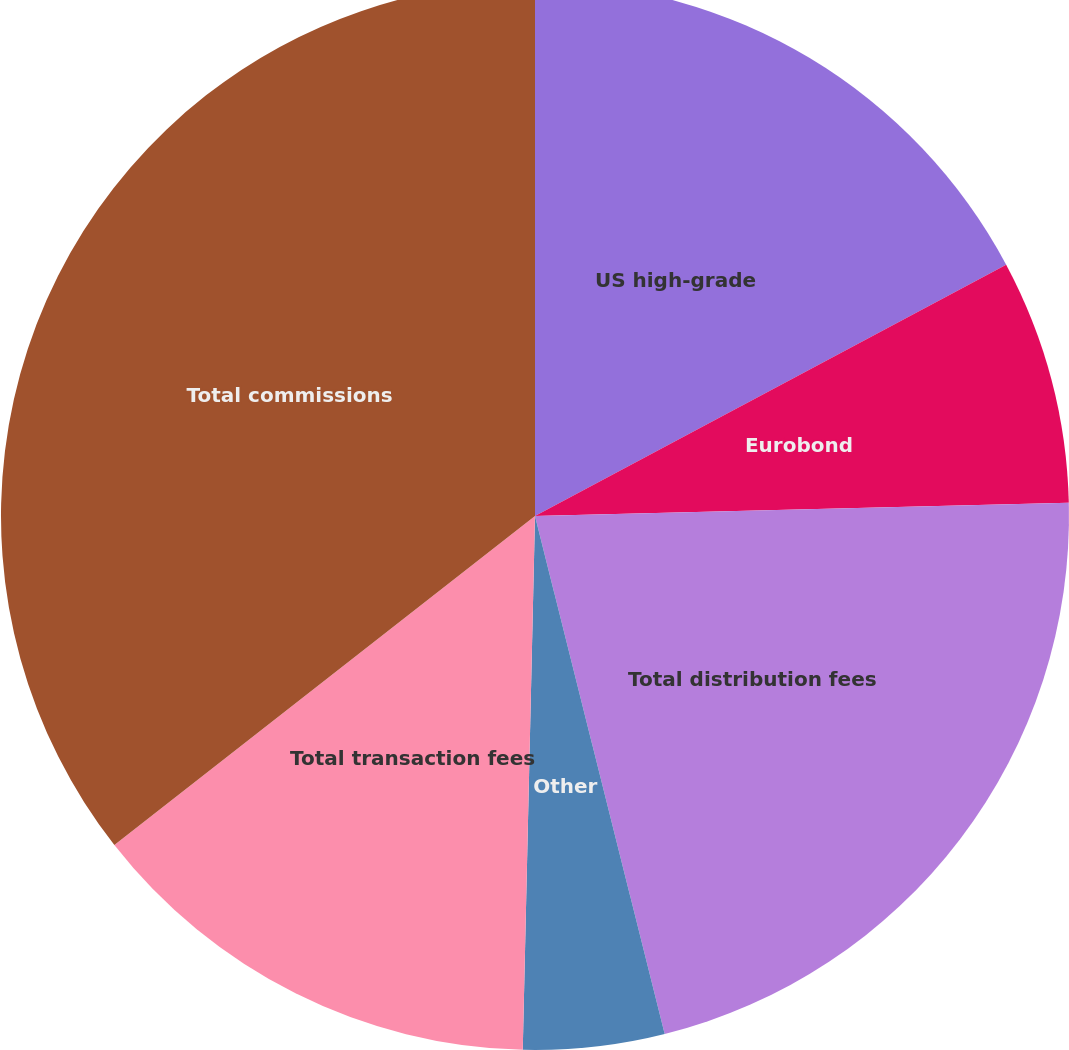<chart> <loc_0><loc_0><loc_500><loc_500><pie_chart><fcel>US high-grade<fcel>Eurobond<fcel>Total distribution fees<fcel>Other<fcel>Total transaction fees<fcel>Total commissions<nl><fcel>17.2%<fcel>7.4%<fcel>21.49%<fcel>4.27%<fcel>14.07%<fcel>35.56%<nl></chart> 